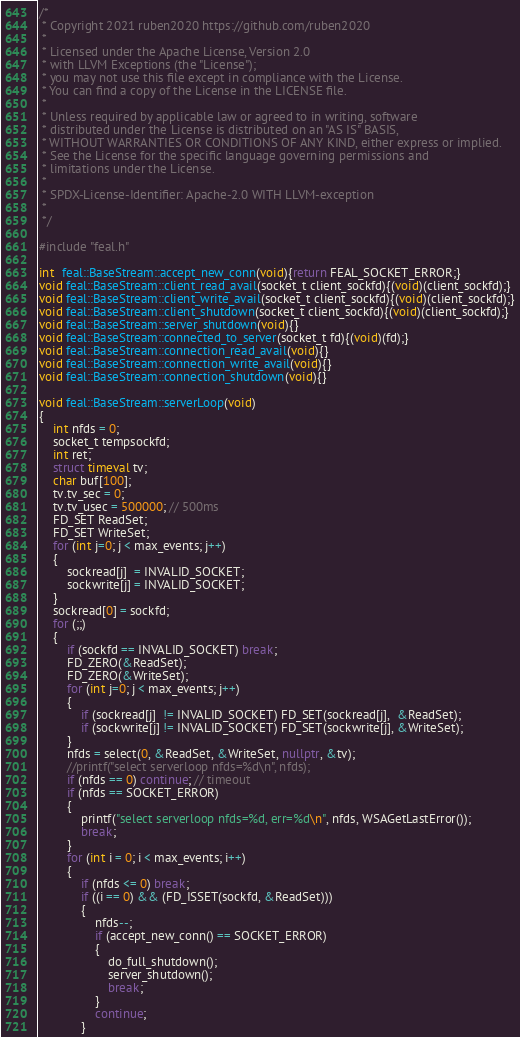<code> <loc_0><loc_0><loc_500><loc_500><_C++_>/*
 * Copyright 2021 ruben2020 https://github.com/ruben2020
 *
 * Licensed under the Apache License, Version 2.0
 * with LLVM Exceptions (the "License");
 * you may not use this file except in compliance with the License.
 * You can find a copy of the License in the LICENSE file.
 *
 * Unless required by applicable law or agreed to in writing, software
 * distributed under the License is distributed on an "AS IS" BASIS,
 * WITHOUT WARRANTIES OR CONDITIONS OF ANY KIND, either express or implied.
 * See the License for the specific language governing permissions and
 * limitations under the License.
 * 
 * SPDX-License-Identifier: Apache-2.0 WITH LLVM-exception
 * 
 */
 
#include "feal.h"

int  feal::BaseStream::accept_new_conn(void){return FEAL_SOCKET_ERROR;}
void feal::BaseStream::client_read_avail(socket_t client_sockfd){(void)(client_sockfd);}
void feal::BaseStream::client_write_avail(socket_t client_sockfd){(void)(client_sockfd);}
void feal::BaseStream::client_shutdown(socket_t client_sockfd){(void)(client_sockfd);}
void feal::BaseStream::server_shutdown(void){}
void feal::BaseStream::connected_to_server(socket_t fd){(void)(fd);}
void feal::BaseStream::connection_read_avail(void){}
void feal::BaseStream::connection_write_avail(void){}
void feal::BaseStream::connection_shutdown(void){}

void feal::BaseStream::serverLoop(void)
{
    int nfds = 0;
    socket_t tempsockfd;
    int ret;
    struct timeval tv;
    char buf[100];
    tv.tv_sec = 0;
    tv.tv_usec = 500000; // 500ms
    FD_SET ReadSet;
    FD_SET WriteSet;
    for (int j=0; j < max_events; j++)
    {
        sockread[j]  = INVALID_SOCKET;
        sockwrite[j] = INVALID_SOCKET;
    }
    sockread[0] = sockfd;
    for (;;)
    {
        if (sockfd == INVALID_SOCKET) break;
        FD_ZERO(&ReadSet);
        FD_ZERO(&WriteSet);
        for (int j=0; j < max_events; j++)
        {
            if (sockread[j]  != INVALID_SOCKET) FD_SET(sockread[j],  &ReadSet);
            if (sockwrite[j] != INVALID_SOCKET) FD_SET(sockwrite[j], &WriteSet);
        }
        nfds = select(0, &ReadSet, &WriteSet, nullptr, &tv);
        //printf("select serverloop nfds=%d\n", nfds);
        if (nfds == 0) continue; // timeout
        if (nfds == SOCKET_ERROR)
        {
            printf("select serverloop nfds=%d, err=%d\n", nfds, WSAGetLastError());
            break;
        }
        for (int i = 0; i < max_events; i++)
        {
            if (nfds <= 0) break;
            if ((i == 0) && (FD_ISSET(sockfd, &ReadSet)))
            {
                nfds--;
                if (accept_new_conn() == SOCKET_ERROR)
                {
                    do_full_shutdown();
                    server_shutdown();
                    break;
                }
                continue;
            }</code> 